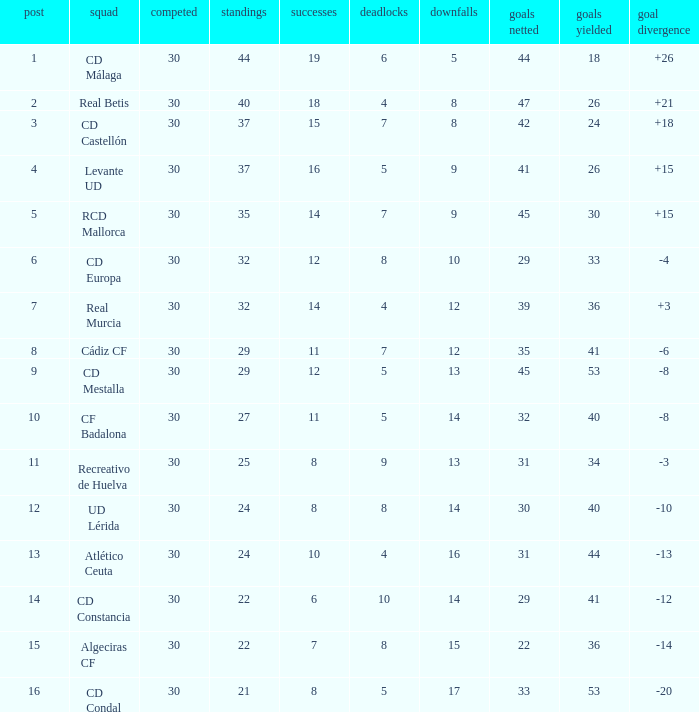What is the number of draws when played is smaller than 30? 0.0. 